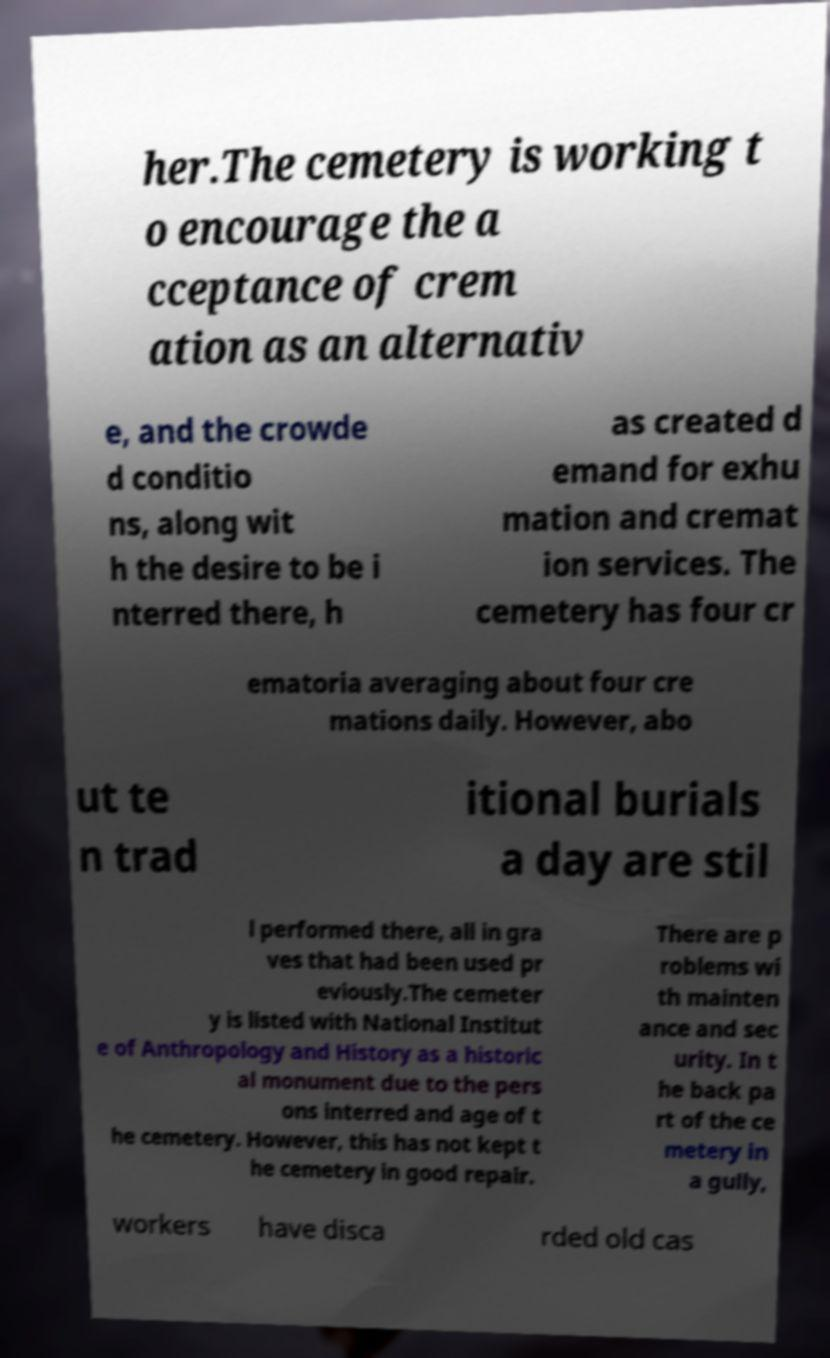There's text embedded in this image that I need extracted. Can you transcribe it verbatim? her.The cemetery is working t o encourage the a cceptance of crem ation as an alternativ e, and the crowde d conditio ns, along wit h the desire to be i nterred there, h as created d emand for exhu mation and cremat ion services. The cemetery has four cr ematoria averaging about four cre mations daily. However, abo ut te n trad itional burials a day are stil l performed there, all in gra ves that had been used pr eviously.The cemeter y is listed with National Institut e of Anthropology and History as a historic al monument due to the pers ons interred and age of t he cemetery. However, this has not kept t he cemetery in good repair. There are p roblems wi th mainten ance and sec urity. In t he back pa rt of the ce metery in a gully, workers have disca rded old cas 